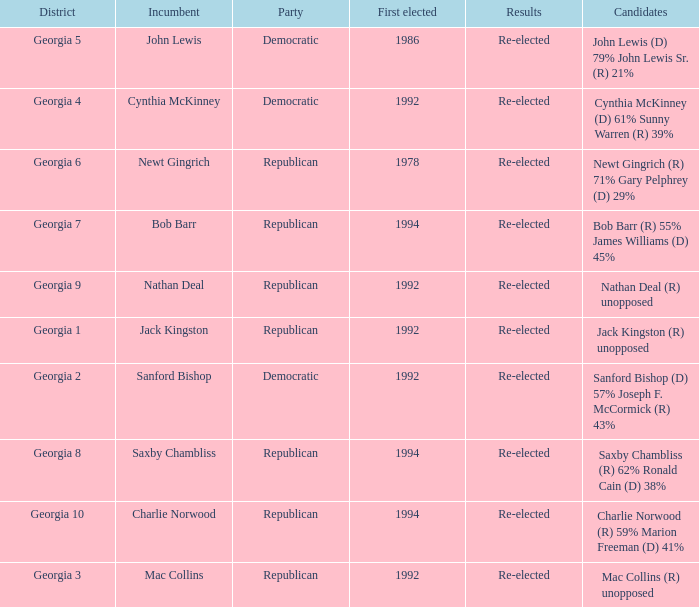Who were the candidates in the election where Saxby Chambliss was the incumbent? Saxby Chambliss (R) 62% Ronald Cain (D) 38%. 